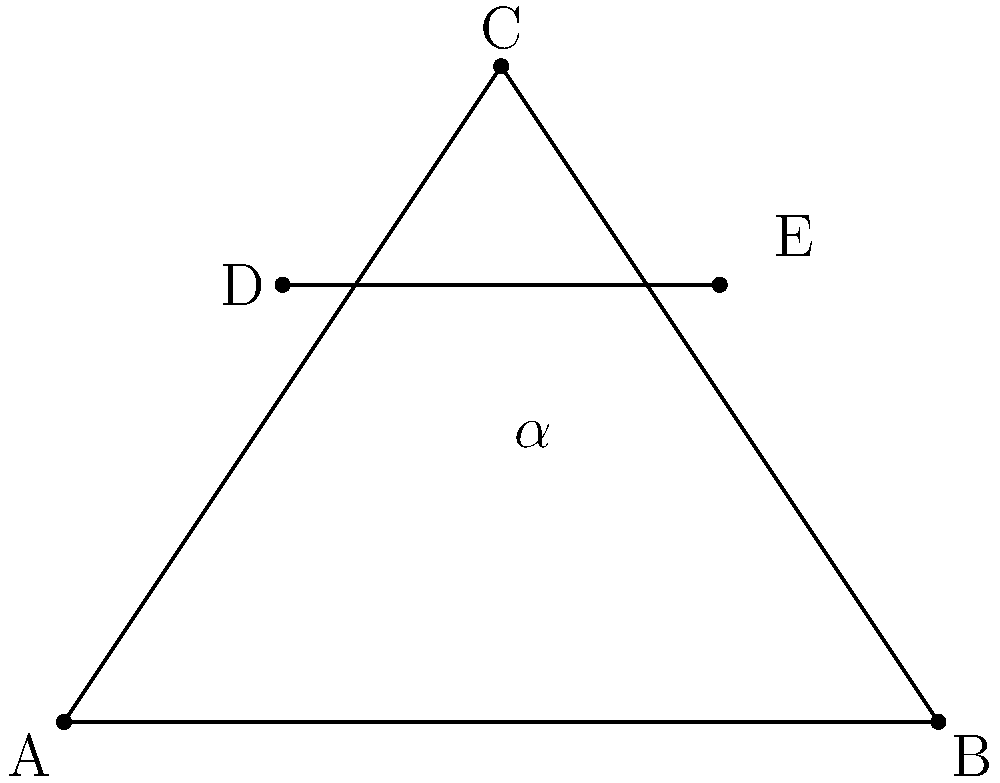In this cubist-inspired composition, lines DE and BC intersect at point F (not shown). Given that $\angle CAB = 60°$ and $\angle CBA = 30°$, determine the measure of angle $\alpha$ formed by the intersection of DE and AB. To solve this problem, we'll follow these steps:

1) First, we need to find $\angle ACB$:
   $\angle ACB = 180° - (\angle CAB + \angle CBA) = 180° - (60° + 30°) = 90°$

2) Triangle ABC is now a 30-60-90 triangle. In such a triangle, if we denote the shortest side (opposite to 30°) as x, then:
   - The hypotenuse (opposite to 90°) is 2x
   - The remaining side (opposite to 60°) is $x\sqrt{3}$

3) Let's say AB = 2x (hypotenuse). Then BC = $x\sqrt{3}$

4) In a 30-60-90 triangle, the altitude to the hypotenuse divides it into two equal parts. This means D is the midpoint of AB.

5) DE is parallel to BC because they both form the same angle with AB (alternate angles are equal).

6) When a line is parallel to one side of a triangle and intersects the other two sides, it divides those sides proportionally. Here, AD:DB = AE:EB = 1:1

7) Since D is the midpoint of AB, E must be the midpoint of AC.

8) In a right triangle, the line segment from the right angle to the midpoint of the hypotenuse is half the length of the hypotenuse. So, CE = AB/2 = x

9) Now we have a 30-60-90 triangle CEB, where CE = x, CB = $x\sqrt{3}$, and EB = x

10) $\alpha = \angle CEB = 60°$ (the largest angle in a 30-60-90 triangle)

Therefore, the measure of angle $\alpha$ is 60°.
Answer: $60°$ 